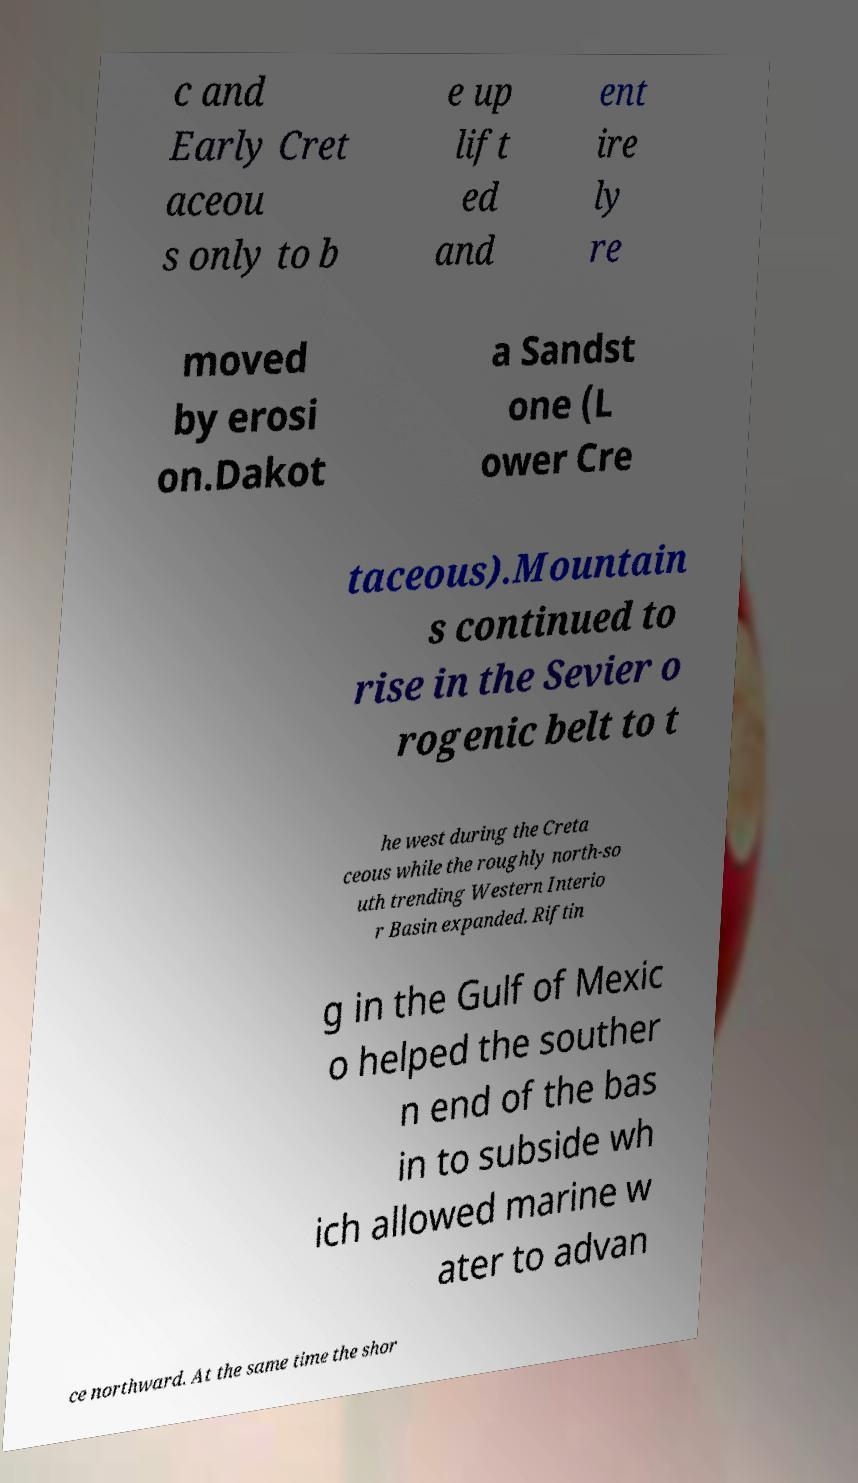I need the written content from this picture converted into text. Can you do that? c and Early Cret aceou s only to b e up lift ed and ent ire ly re moved by erosi on.Dakot a Sandst one (L ower Cre taceous).Mountain s continued to rise in the Sevier o rogenic belt to t he west during the Creta ceous while the roughly north-so uth trending Western Interio r Basin expanded. Riftin g in the Gulf of Mexic o helped the souther n end of the bas in to subside wh ich allowed marine w ater to advan ce northward. At the same time the shor 